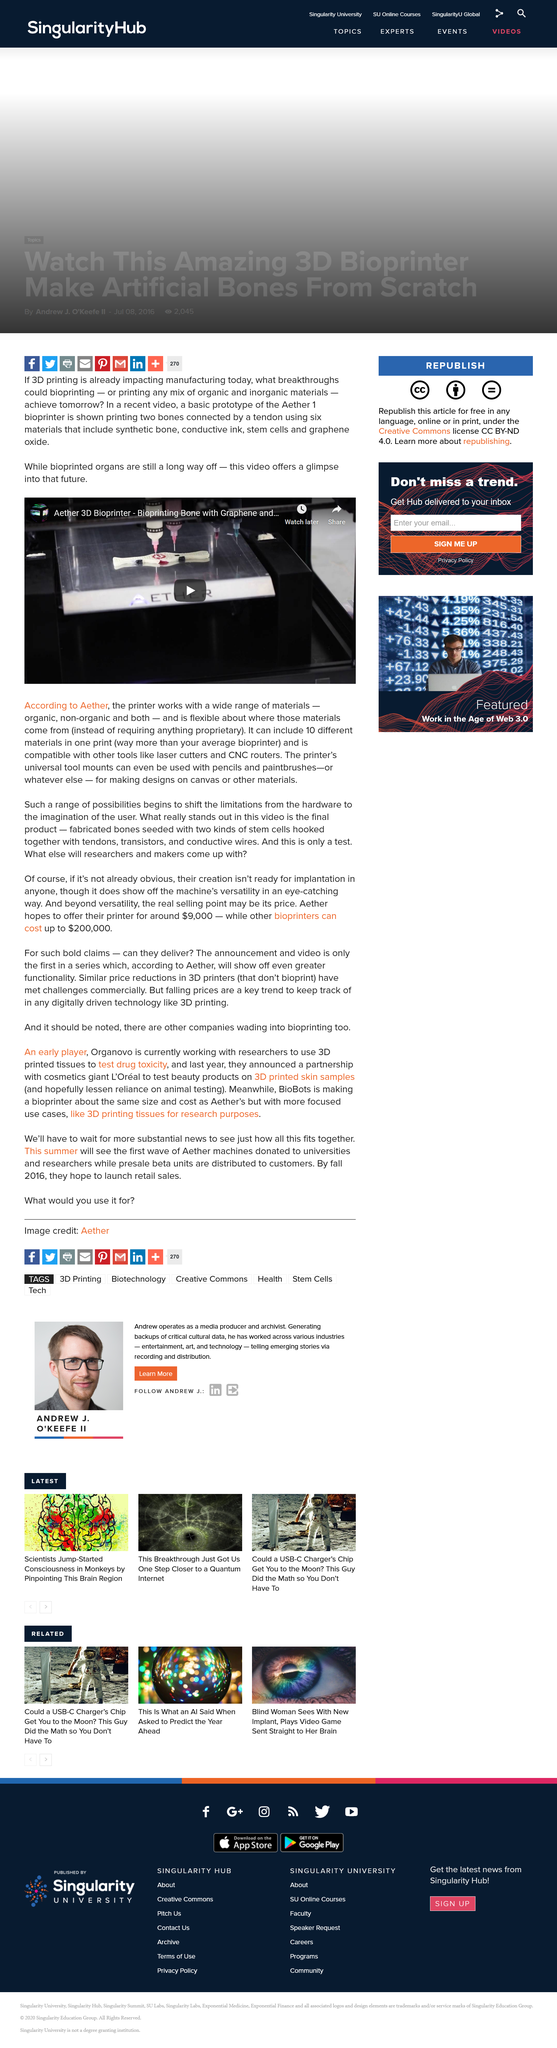Specify some key components in this picture. The Aether 3D printer is capable of printing with up to 10 different materials, allowing for a wide range of creative possibilities in terms of the final product's appearance and functionality. The Aether 3D printer is capable of printing with both organic and non-organic materials. 